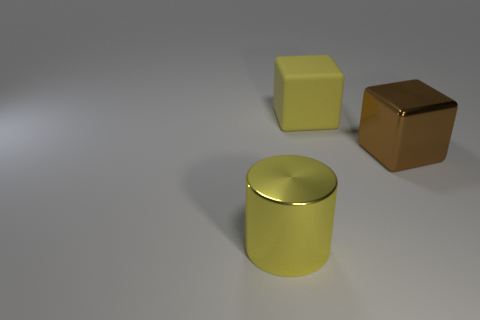What number of spheres are either shiny things or brown shiny objects?
Offer a terse response. 0. There is a thing that is the same color as the big rubber block; what is its size?
Ensure brevity in your answer.  Large. Is the number of brown blocks that are behind the large yellow rubber thing less than the number of small blue blocks?
Give a very brief answer. No. The large thing that is right of the metal cylinder and in front of the big rubber object is what color?
Your answer should be compact. Brown. How many other objects are there of the same shape as the big brown thing?
Provide a short and direct response. 1. Is the number of big blocks in front of the yellow rubber object less than the number of shiny cylinders right of the large brown block?
Provide a short and direct response. No. Does the cylinder have the same material as the big thing that is to the right of the big rubber object?
Ensure brevity in your answer.  Yes. Is there anything else that is the same material as the large brown thing?
Your response must be concise. Yes. Are there more large red spheres than big brown metal cubes?
Offer a very short reply. No. The big metal object on the left side of the metallic thing right of the large yellow object in front of the large brown shiny object is what shape?
Your response must be concise. Cylinder. 